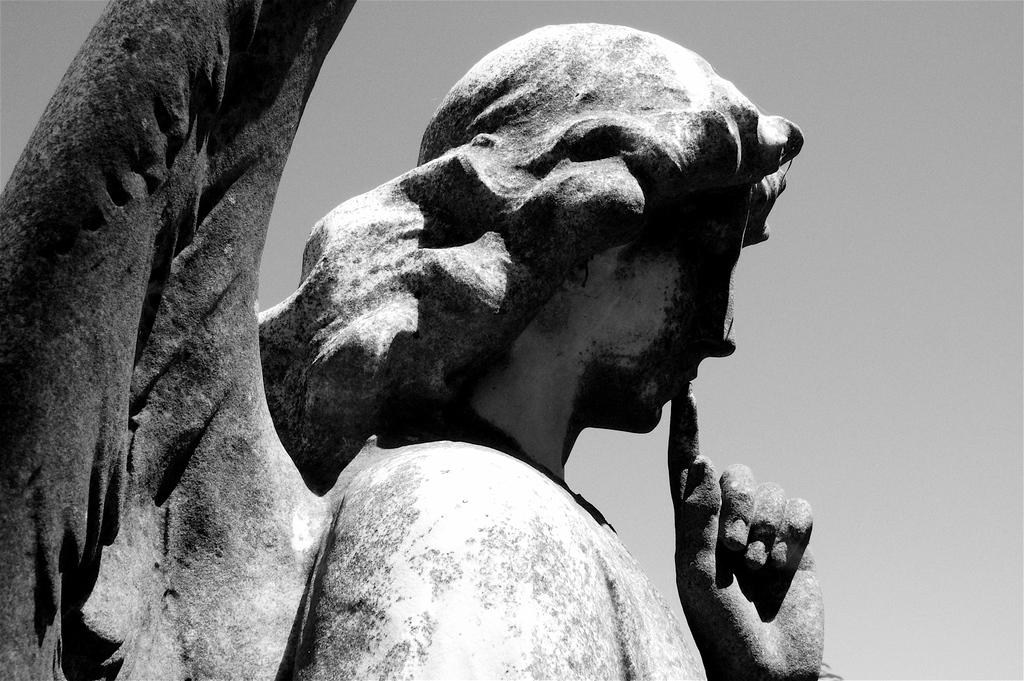What type of material is used to create the sculpture in the image? The sculpture in the image is made up of rock. What can be seen in the background of the image? The background of the image includes the sky. What year was the house built in the image? There is no house present in the image, so it is not possible to determine the year it was built. 